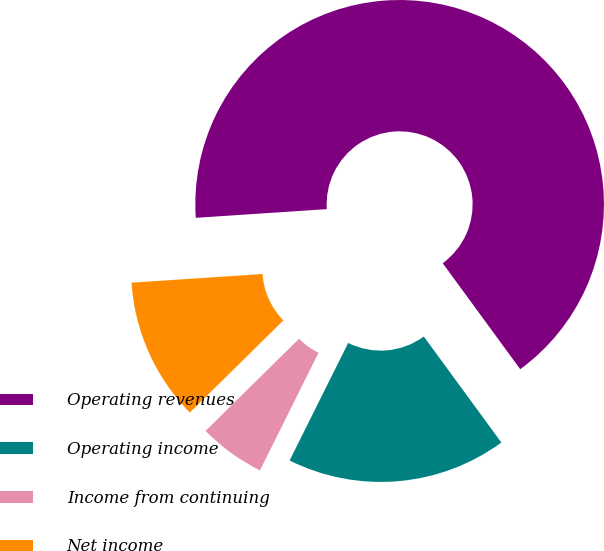<chart> <loc_0><loc_0><loc_500><loc_500><pie_chart><fcel>Operating revenues<fcel>Operating income<fcel>Income from continuing<fcel>Net income<nl><fcel>66.01%<fcel>17.41%<fcel>5.26%<fcel>11.33%<nl></chart> 